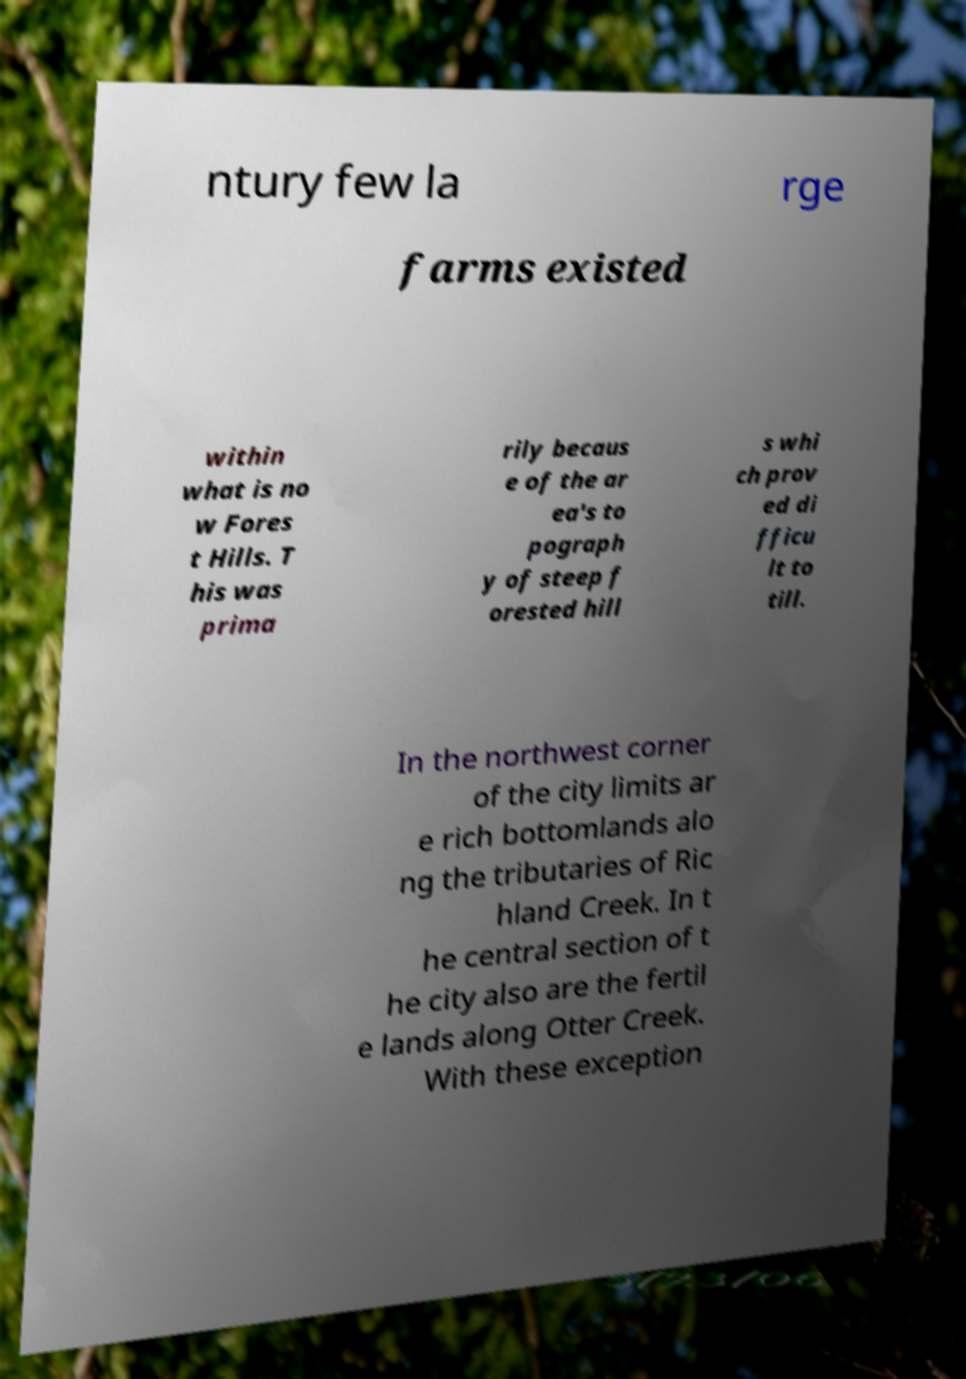Can you read and provide the text displayed in the image?This photo seems to have some interesting text. Can you extract and type it out for me? ntury few la rge farms existed within what is no w Fores t Hills. T his was prima rily becaus e of the ar ea's to pograph y of steep f orested hill s whi ch prov ed di fficu lt to till. In the northwest corner of the city limits ar e rich bottomlands alo ng the tributaries of Ric hland Creek. In t he central section of t he city also are the fertil e lands along Otter Creek. With these exception 